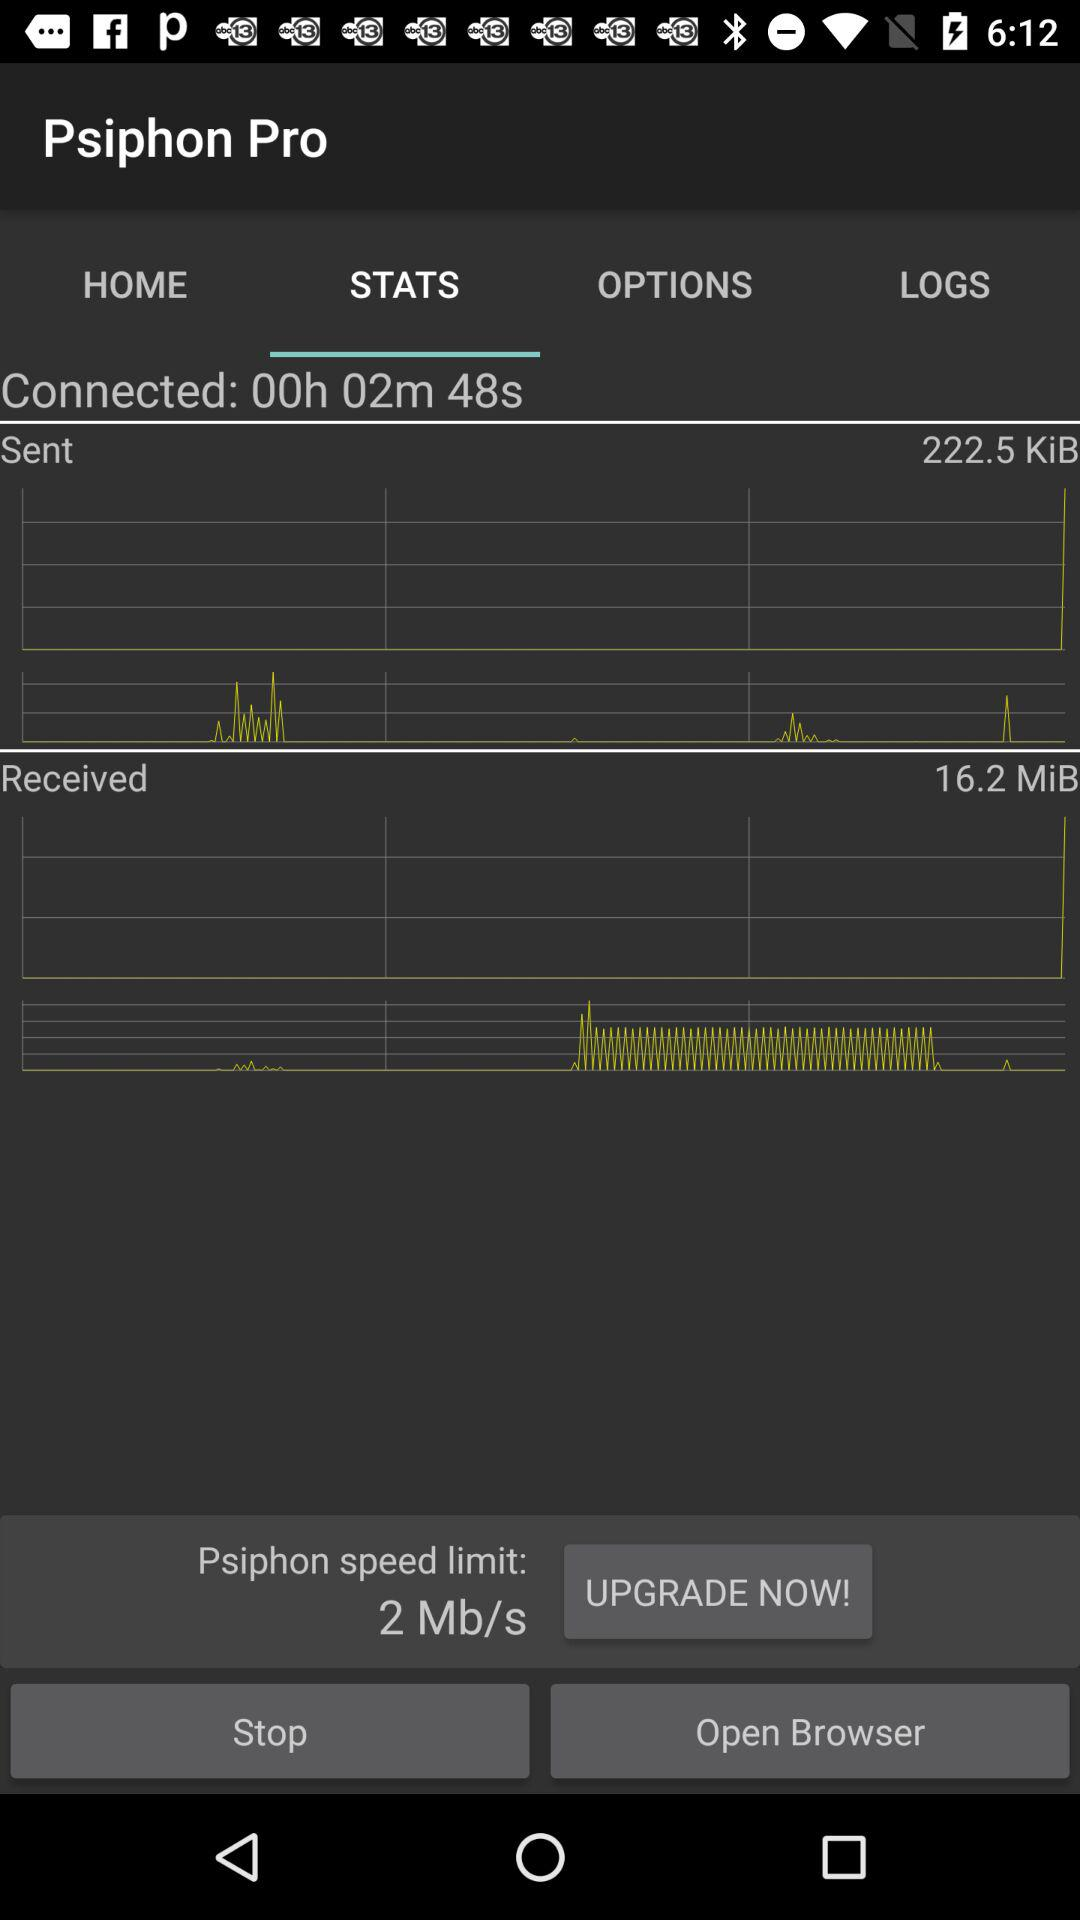How much data has been sent? The sent amount of data is 222.5 KiB. 